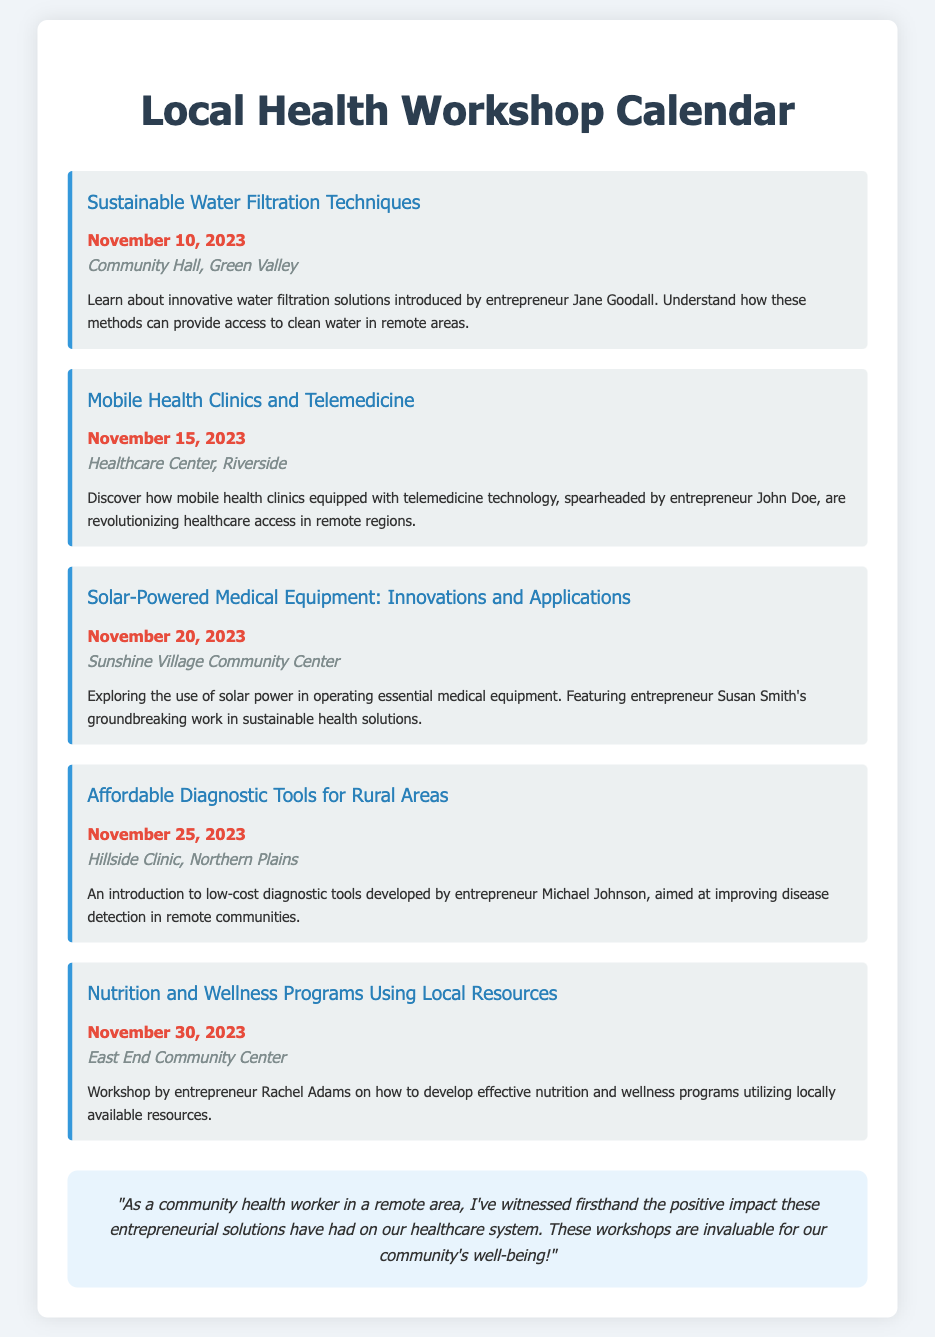What is the date of the workshop on Sustainable Water Filtration Techniques? The date of the workshop is mentioned directly in the event details.
Answer: November 10, 2023 Where will the Mobile Health Clinics and Telemedicine workshop take place? The location is specified in the event details of the workshop.
Answer: Healthcare Center, Riverside Who is the entrepreneur featured in the Solar-Powered Medical Equipment workshop? The entrepreneur's name is included in the event description.
Answer: Susan Smith How many workshops are scheduled in November 2023? The total number of events listed in the document gives the answer.
Answer: 5 What is the main topic of the workshop on November 30, 2023? The event title provides information about the topic of the workshop.
Answer: Nutrition and Wellness Programs Using Local Resources Which entrepreneur is associated with the Affordable Diagnostic Tools workshop? The event description names the entrepreneur linked to this workshop.
Answer: Michael Johnson What is the focus of the workshop on November 15, 2023? The focus is indicated in the event description for this date.
Answer: Mobile Health Clinics and Telemedicine What color is used for the event titles in the calendar? The style guidelines in the code specify the color used for event titles.
Answer: #2980b9 